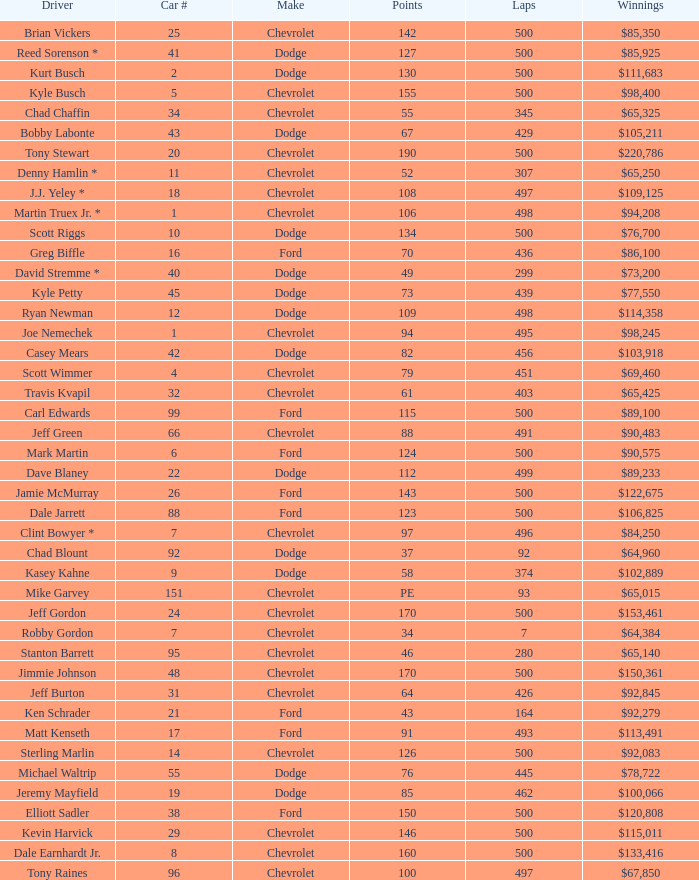What make of car did Brian Vickers drive? Chevrolet. 